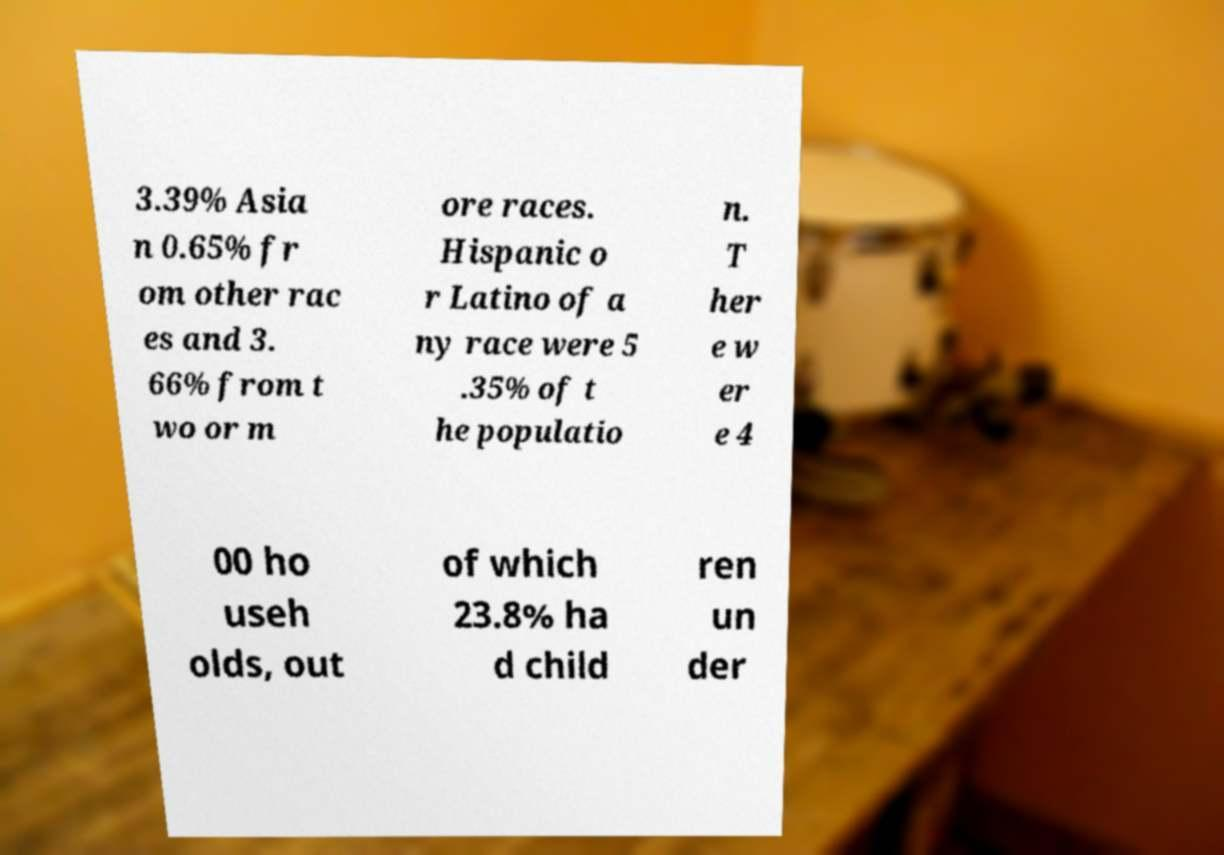I need the written content from this picture converted into text. Can you do that? 3.39% Asia n 0.65% fr om other rac es and 3. 66% from t wo or m ore races. Hispanic o r Latino of a ny race were 5 .35% of t he populatio n. T her e w er e 4 00 ho useh olds, out of which 23.8% ha d child ren un der 